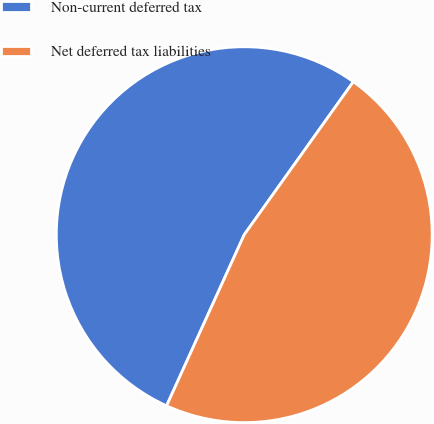<chart> <loc_0><loc_0><loc_500><loc_500><pie_chart><fcel>Non-current deferred tax<fcel>Net deferred tax liabilities<nl><fcel>53.08%<fcel>46.92%<nl></chart> 